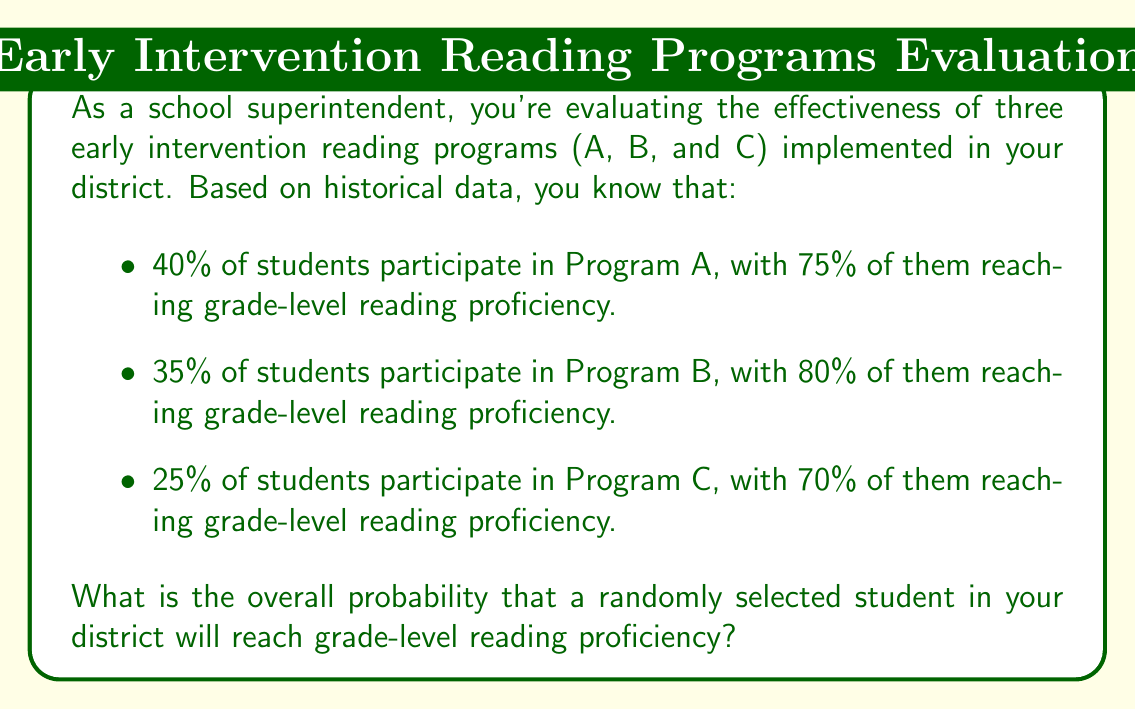Can you answer this question? To solve this problem, we'll use the law of total probability. Let's break it down step by step:

1) Let's define our events:
   R: The event that a student reaches grade-level reading proficiency
   A: The event that a student participates in Program A
   B: The event that a student participates in Program B
   C: The event that a student participates in Program C

2) We're given the following probabilities:
   $P(A) = 0.40$, $P(B) = 0.35$, $P(C) = 0.25$
   $P(R|A) = 0.75$, $P(R|B) = 0.80$, $P(R|C) = 0.70$

3) The law of total probability states:
   $$P(R) = P(R|A)P(A) + P(R|B)P(B) + P(R|C)P(C)$$

4) Let's substitute our known values:
   $$P(R) = (0.75)(0.40) + (0.80)(0.35) + (0.70)(0.25)$$

5) Now, let's calculate:
   $$P(R) = 0.30 + 0.28 + 0.175 = 0.755$$

Therefore, the overall probability that a randomly selected student will reach grade-level reading proficiency is 0.755 or 75.5%.
Answer: 0.755 or 75.5% 